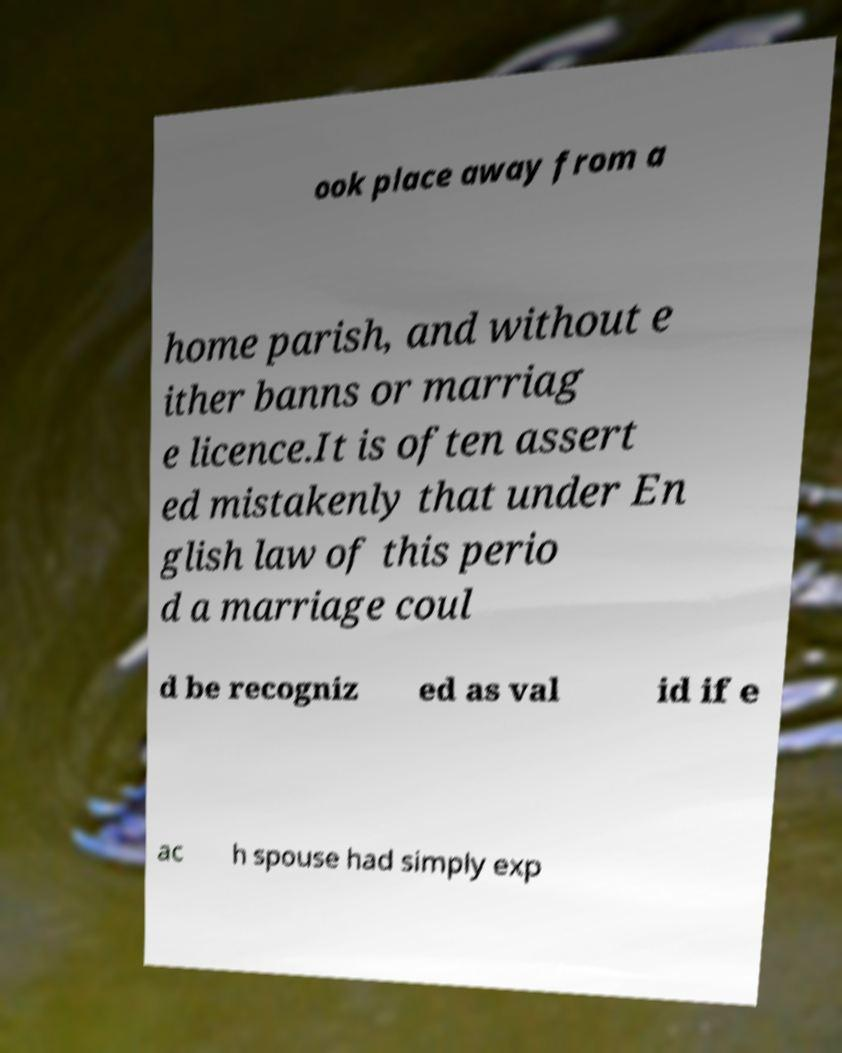Please read and relay the text visible in this image. What does it say? ook place away from a home parish, and without e ither banns or marriag e licence.It is often assert ed mistakenly that under En glish law of this perio d a marriage coul d be recogniz ed as val id if e ac h spouse had simply exp 